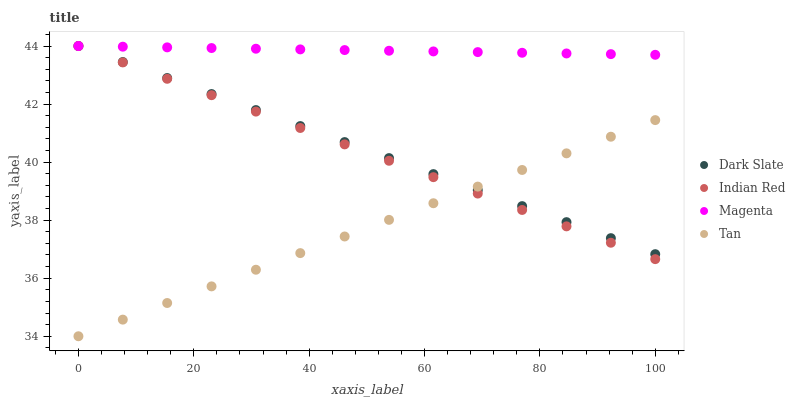Does Tan have the minimum area under the curve?
Answer yes or no. Yes. Does Magenta have the maximum area under the curve?
Answer yes or no. Yes. Does Magenta have the minimum area under the curve?
Answer yes or no. No. Does Tan have the maximum area under the curve?
Answer yes or no. No. Is Magenta the smoothest?
Answer yes or no. Yes. Is Tan the roughest?
Answer yes or no. Yes. Is Tan the smoothest?
Answer yes or no. No. Is Magenta the roughest?
Answer yes or no. No. Does Tan have the lowest value?
Answer yes or no. Yes. Does Magenta have the lowest value?
Answer yes or no. No. Does Indian Red have the highest value?
Answer yes or no. Yes. Does Tan have the highest value?
Answer yes or no. No. Is Tan less than Magenta?
Answer yes or no. Yes. Is Magenta greater than Tan?
Answer yes or no. Yes. Does Dark Slate intersect Indian Red?
Answer yes or no. Yes. Is Dark Slate less than Indian Red?
Answer yes or no. No. Is Dark Slate greater than Indian Red?
Answer yes or no. No. Does Tan intersect Magenta?
Answer yes or no. No. 